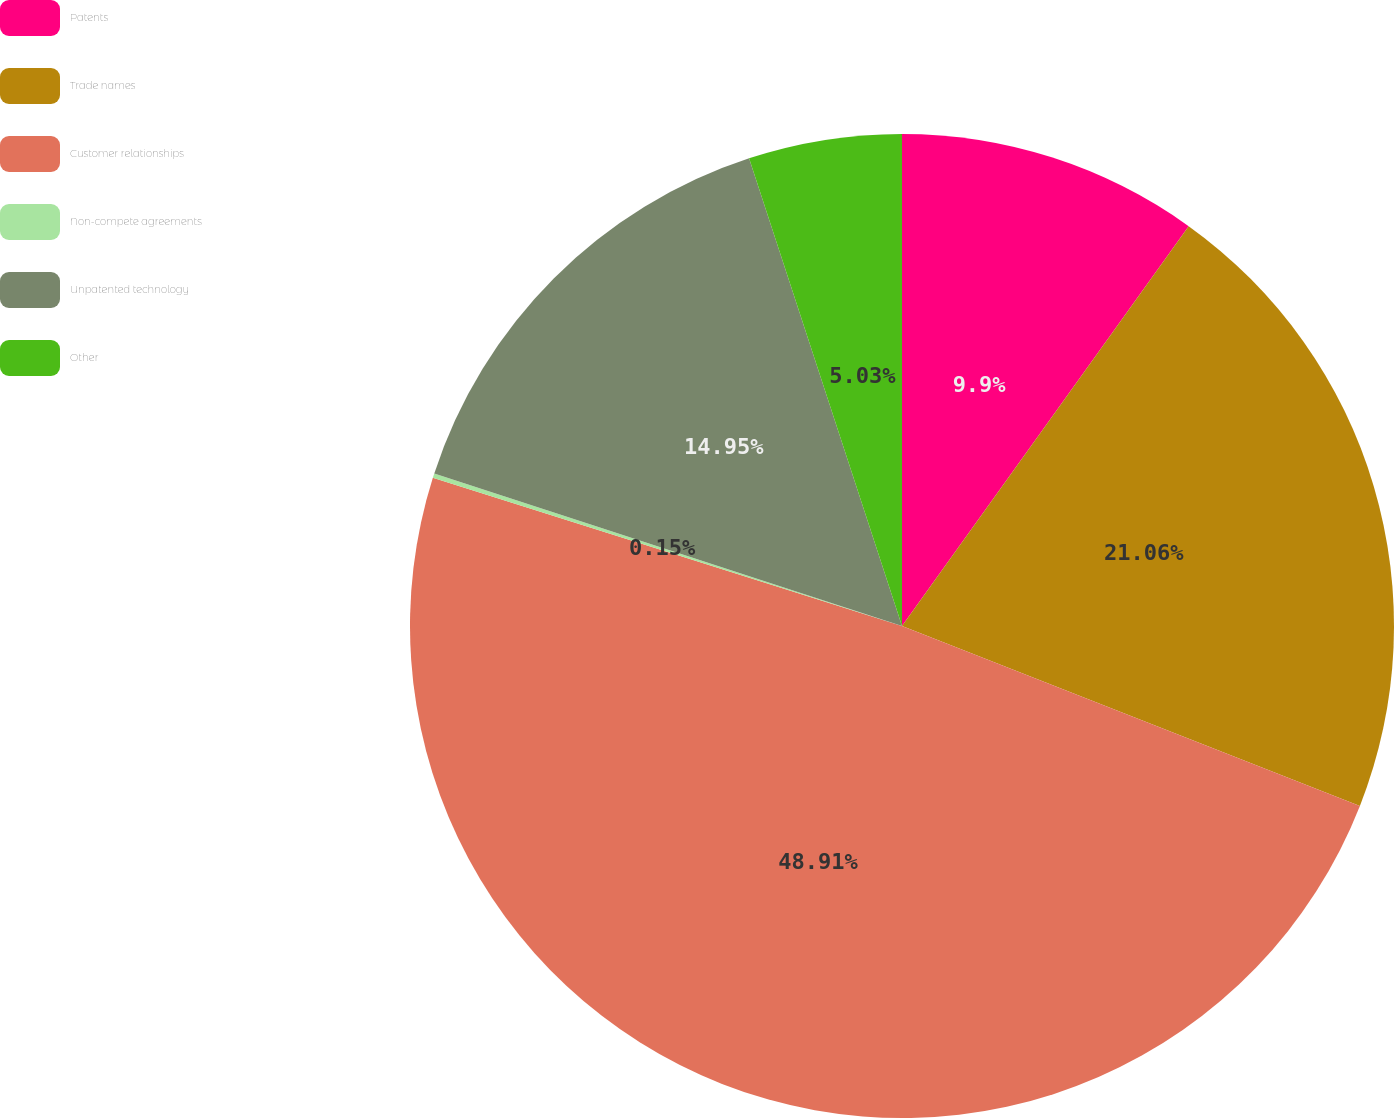Convert chart. <chart><loc_0><loc_0><loc_500><loc_500><pie_chart><fcel>Patents<fcel>Trade names<fcel>Customer relationships<fcel>Non-compete agreements<fcel>Unpatented technology<fcel>Other<nl><fcel>9.9%<fcel>21.06%<fcel>48.91%<fcel>0.15%<fcel>14.95%<fcel>5.03%<nl></chart> 